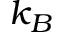Convert formula to latex. <formula><loc_0><loc_0><loc_500><loc_500>k _ { B }</formula> 